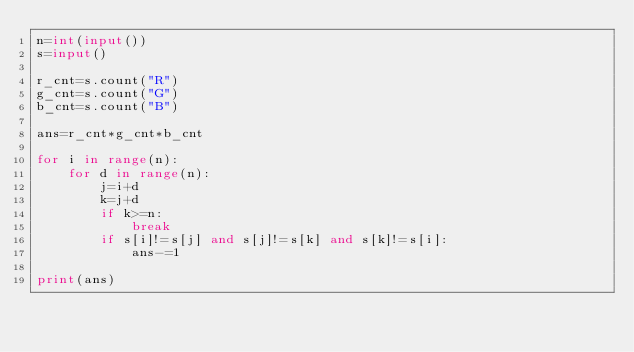<code> <loc_0><loc_0><loc_500><loc_500><_Python_>n=int(input())
s=input()

r_cnt=s.count("R")
g_cnt=s.count("G")
b_cnt=s.count("B")

ans=r_cnt*g_cnt*b_cnt

for i in range(n):
    for d in range(n):
        j=i+d
        k=j+d
        if k>=n:
            break
        if s[i]!=s[j] and s[j]!=s[k] and s[k]!=s[i]:
            ans-=1

print(ans)   </code> 